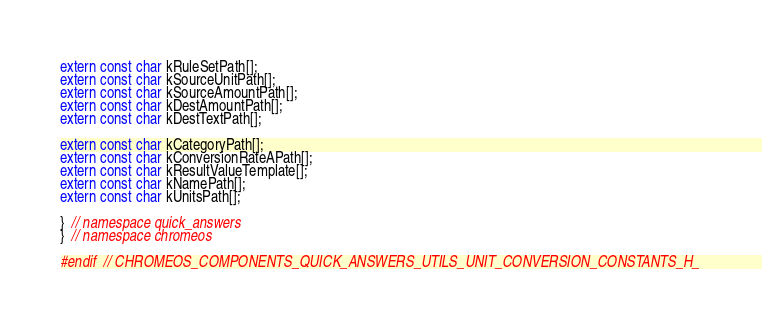<code> <loc_0><loc_0><loc_500><loc_500><_C_>extern const char kRuleSetPath[];
extern const char kSourceUnitPath[];
extern const char kSourceAmountPath[];
extern const char kDestAmountPath[];
extern const char kDestTextPath[];

extern const char kCategoryPath[];
extern const char kConversionRateAPath[];
extern const char kResultValueTemplate[];
extern const char kNamePath[];
extern const char kUnitsPath[];

}  // namespace quick_answers
}  // namespace chromeos

#endif  // CHROMEOS_COMPONENTS_QUICK_ANSWERS_UTILS_UNIT_CONVERSION_CONSTANTS_H_
</code> 